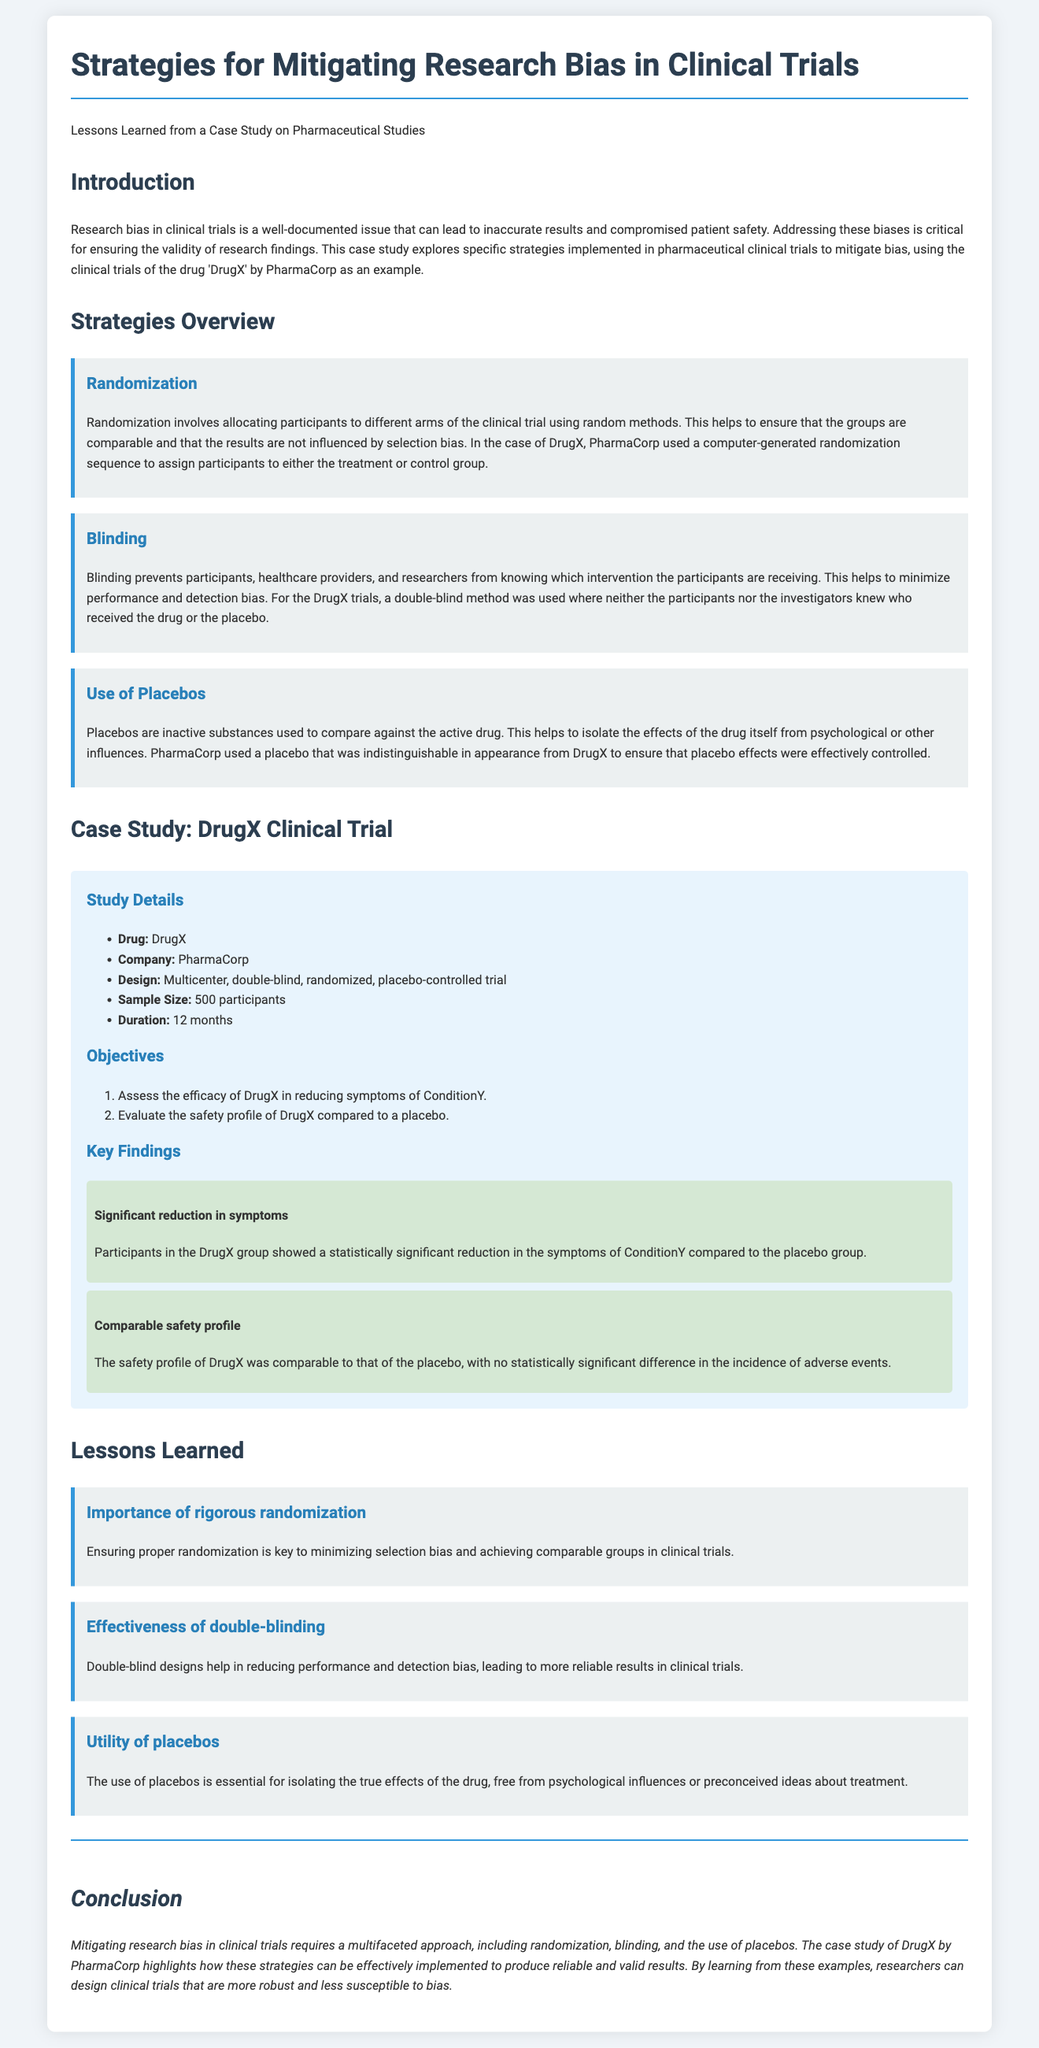What is the drug studied in the clinical trial? The drug studied in the clinical trial is mentioned in the "Case Study: DrugX Clinical Trial" section, which states "DrugX."
Answer: DrugX What company conducted the clinical trial? The company that conducted the clinical trial is identified in the same section, stating "PharmaCorp."
Answer: PharmaCorp What was the sample size of the clinical trial? The sample size is listed under "Study Details," where it states "500 participants."
Answer: 500 participants What type of clinical trial design was used? The design type is specified as "Multicenter, double-blind, randomized, placebo-controlled trial" in "Study Details."
Answer: Multicenter, double-blind, randomized, placebo-controlled trial What is the duration of the clinical trial? The duration is noted in the "Study Details" section as "12 months."
Answer: 12 months What was one of the objectives of the clinical trial? One of the objectives is listed under "Objectives," which states "Assess the efficacy of DrugX in reducing symptoms of ConditionY."
Answer: Assess the efficacy of DrugX in reducing symptoms of ConditionY What strategy helped minimize selection bias? The strategy that helped minimize selection bias is described under "Strategies Overview," mentioning "Randomization."
Answer: Randomization How did PharmaCorp ensure the placebo was effective? The document states under "Use of Placebos" that "PharmaCorp used a placebo that was indistinguishable in appearance from DrugX."
Answer: Indistinguishable in appearance from DrugX What does double-blinding help to reduce? The effectiveness of double-blinding is elaborated upon, indicating it helps to reduce "performance and detection bias."
Answer: Performance and detection bias 